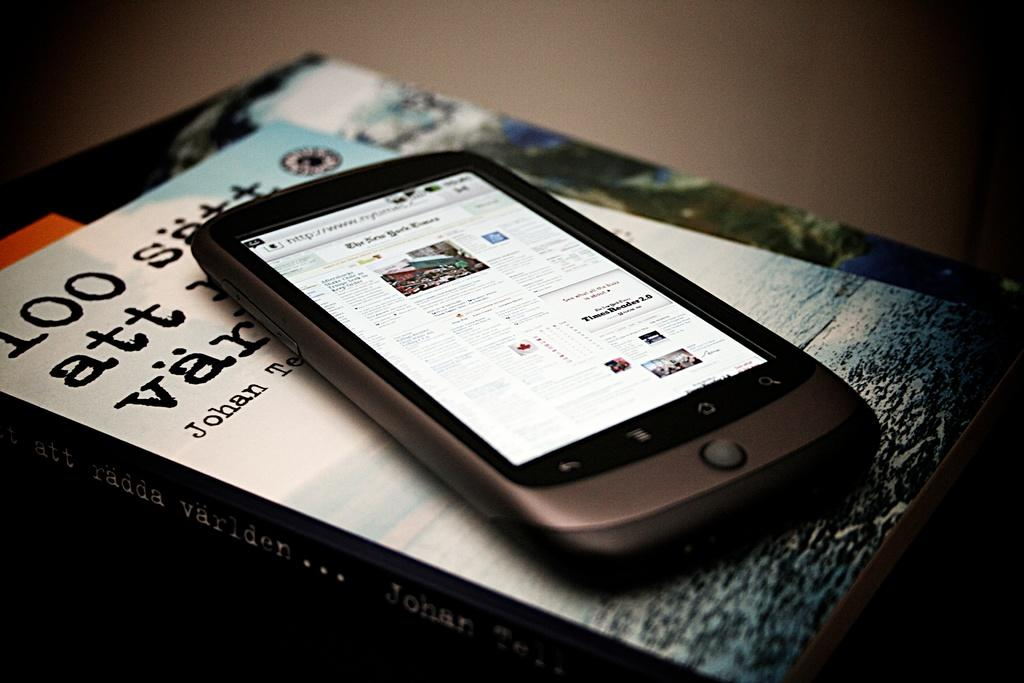<image>
Give a short and clear explanation of the subsequent image. A cellphone is sitting on top of a book with the name Johan on it. 